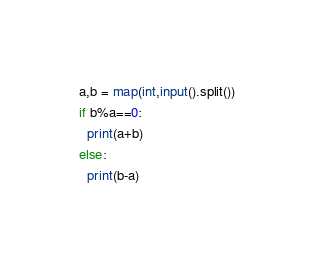Convert code to text. <code><loc_0><loc_0><loc_500><loc_500><_Python_>a,b = map(int,input().split())
if b%a==0:
  print(a+b)
else:
  print(b-a)</code> 